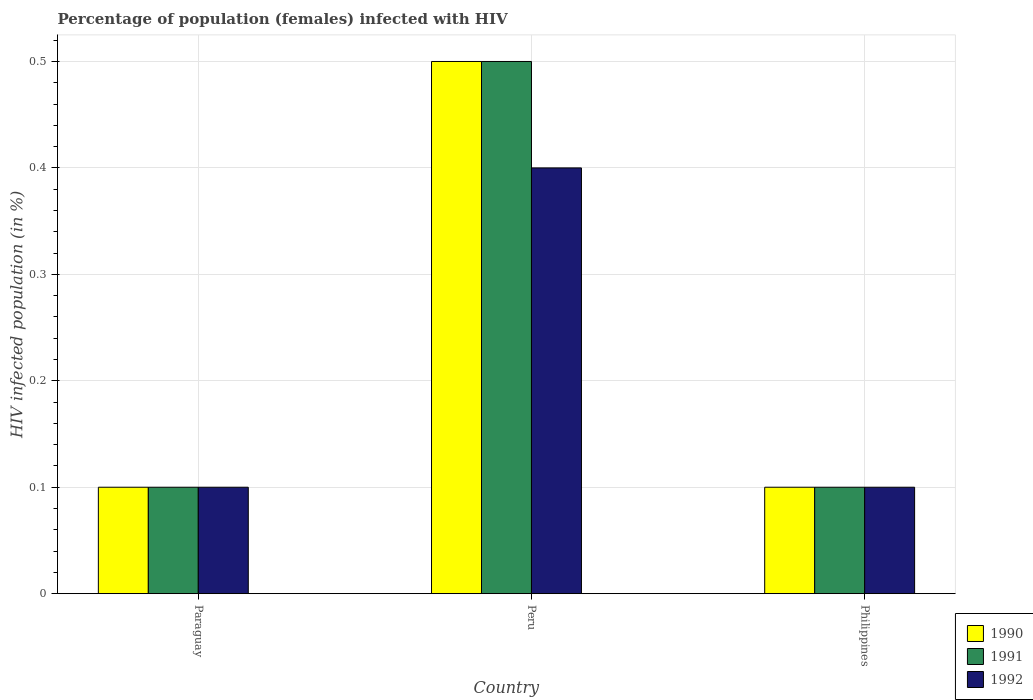How many different coloured bars are there?
Offer a terse response. 3. How many groups of bars are there?
Give a very brief answer. 3. Are the number of bars on each tick of the X-axis equal?
Give a very brief answer. Yes. What is the label of the 1st group of bars from the left?
Give a very brief answer. Paraguay. In how many cases, is the number of bars for a given country not equal to the number of legend labels?
Keep it short and to the point. 0. In which country was the percentage of HIV infected female population in 1992 maximum?
Offer a terse response. Peru. In which country was the percentage of HIV infected female population in 1990 minimum?
Your response must be concise. Paraguay. What is the difference between the percentage of HIV infected female population in 1991 in Paraguay and that in Philippines?
Keep it short and to the point. 0. What is the difference between the percentage of HIV infected female population in 1990 in Philippines and the percentage of HIV infected female population in 1992 in Paraguay?
Ensure brevity in your answer.  0. What is the average percentage of HIV infected female population in 1992 per country?
Your answer should be very brief. 0.2. What is the difference between the percentage of HIV infected female population of/in 1991 and percentage of HIV infected female population of/in 1992 in Peru?
Offer a terse response. 0.1. What is the ratio of the percentage of HIV infected female population in 1991 in Peru to that in Philippines?
Give a very brief answer. 5. Is the difference between the percentage of HIV infected female population in 1991 in Peru and Philippines greater than the difference between the percentage of HIV infected female population in 1992 in Peru and Philippines?
Ensure brevity in your answer.  Yes. What is the difference between the highest and the lowest percentage of HIV infected female population in 1992?
Your response must be concise. 0.3. Is the sum of the percentage of HIV infected female population in 1991 in Paraguay and Philippines greater than the maximum percentage of HIV infected female population in 1990 across all countries?
Your answer should be very brief. No. What does the 2nd bar from the right in Peru represents?
Ensure brevity in your answer.  1991. Is it the case that in every country, the sum of the percentage of HIV infected female population in 1991 and percentage of HIV infected female population in 1992 is greater than the percentage of HIV infected female population in 1990?
Ensure brevity in your answer.  Yes. Are all the bars in the graph horizontal?
Ensure brevity in your answer.  No. How many countries are there in the graph?
Keep it short and to the point. 3. Are the values on the major ticks of Y-axis written in scientific E-notation?
Your answer should be compact. No. Where does the legend appear in the graph?
Ensure brevity in your answer.  Bottom right. What is the title of the graph?
Give a very brief answer. Percentage of population (females) infected with HIV. What is the label or title of the X-axis?
Give a very brief answer. Country. What is the label or title of the Y-axis?
Provide a short and direct response. HIV infected population (in %). What is the HIV infected population (in %) in 1990 in Paraguay?
Your answer should be compact. 0.1. What is the HIV infected population (in %) in 1992 in Paraguay?
Keep it short and to the point. 0.1. What is the HIV infected population (in %) of 1991 in Peru?
Your answer should be very brief. 0.5. What is the HIV infected population (in %) in 1991 in Philippines?
Provide a short and direct response. 0.1. What is the HIV infected population (in %) of 1992 in Philippines?
Keep it short and to the point. 0.1. Across all countries, what is the maximum HIV infected population (in %) of 1990?
Provide a succinct answer. 0.5. Across all countries, what is the maximum HIV infected population (in %) in 1991?
Your response must be concise. 0.5. Across all countries, what is the maximum HIV infected population (in %) of 1992?
Ensure brevity in your answer.  0.4. What is the total HIV infected population (in %) in 1990 in the graph?
Make the answer very short. 0.7. What is the difference between the HIV infected population (in %) in 1992 in Paraguay and that in Peru?
Make the answer very short. -0.3. What is the difference between the HIV infected population (in %) in 1990 in Paraguay and that in Philippines?
Provide a succinct answer. 0. What is the difference between the HIV infected population (in %) in 1991 in Paraguay and that in Philippines?
Your answer should be compact. 0. What is the difference between the HIV infected population (in %) in 1992 in Paraguay and that in Philippines?
Offer a very short reply. 0. What is the difference between the HIV infected population (in %) in 1992 in Peru and that in Philippines?
Offer a very short reply. 0.3. What is the difference between the HIV infected population (in %) in 1991 in Paraguay and the HIV infected population (in %) in 1992 in Peru?
Keep it short and to the point. -0.3. What is the difference between the HIV infected population (in %) in 1990 in Paraguay and the HIV infected population (in %) in 1991 in Philippines?
Ensure brevity in your answer.  0. What is the difference between the HIV infected population (in %) of 1990 in Paraguay and the HIV infected population (in %) of 1992 in Philippines?
Make the answer very short. 0. What is the difference between the HIV infected population (in %) of 1991 in Peru and the HIV infected population (in %) of 1992 in Philippines?
Make the answer very short. 0.4. What is the average HIV infected population (in %) in 1990 per country?
Ensure brevity in your answer.  0.23. What is the average HIV infected population (in %) in 1991 per country?
Your response must be concise. 0.23. What is the difference between the HIV infected population (in %) in 1990 and HIV infected population (in %) in 1992 in Philippines?
Provide a succinct answer. 0. What is the difference between the HIV infected population (in %) in 1991 and HIV infected population (in %) in 1992 in Philippines?
Ensure brevity in your answer.  0. What is the ratio of the HIV infected population (in %) in 1990 in Paraguay to that in Peru?
Provide a succinct answer. 0.2. What is the ratio of the HIV infected population (in %) in 1992 in Paraguay to that in Peru?
Your answer should be compact. 0.25. What is the ratio of the HIV infected population (in %) in 1991 in Paraguay to that in Philippines?
Provide a short and direct response. 1. What is the ratio of the HIV infected population (in %) in 1992 in Paraguay to that in Philippines?
Provide a short and direct response. 1. What is the ratio of the HIV infected population (in %) of 1990 in Peru to that in Philippines?
Give a very brief answer. 5. What is the ratio of the HIV infected population (in %) in 1991 in Peru to that in Philippines?
Your answer should be very brief. 5. What is the ratio of the HIV infected population (in %) in 1992 in Peru to that in Philippines?
Keep it short and to the point. 4. What is the difference between the highest and the second highest HIV infected population (in %) in 1990?
Your answer should be very brief. 0.4. What is the difference between the highest and the second highest HIV infected population (in %) in 1992?
Give a very brief answer. 0.3. What is the difference between the highest and the lowest HIV infected population (in %) of 1990?
Provide a short and direct response. 0.4. What is the difference between the highest and the lowest HIV infected population (in %) of 1992?
Offer a very short reply. 0.3. 